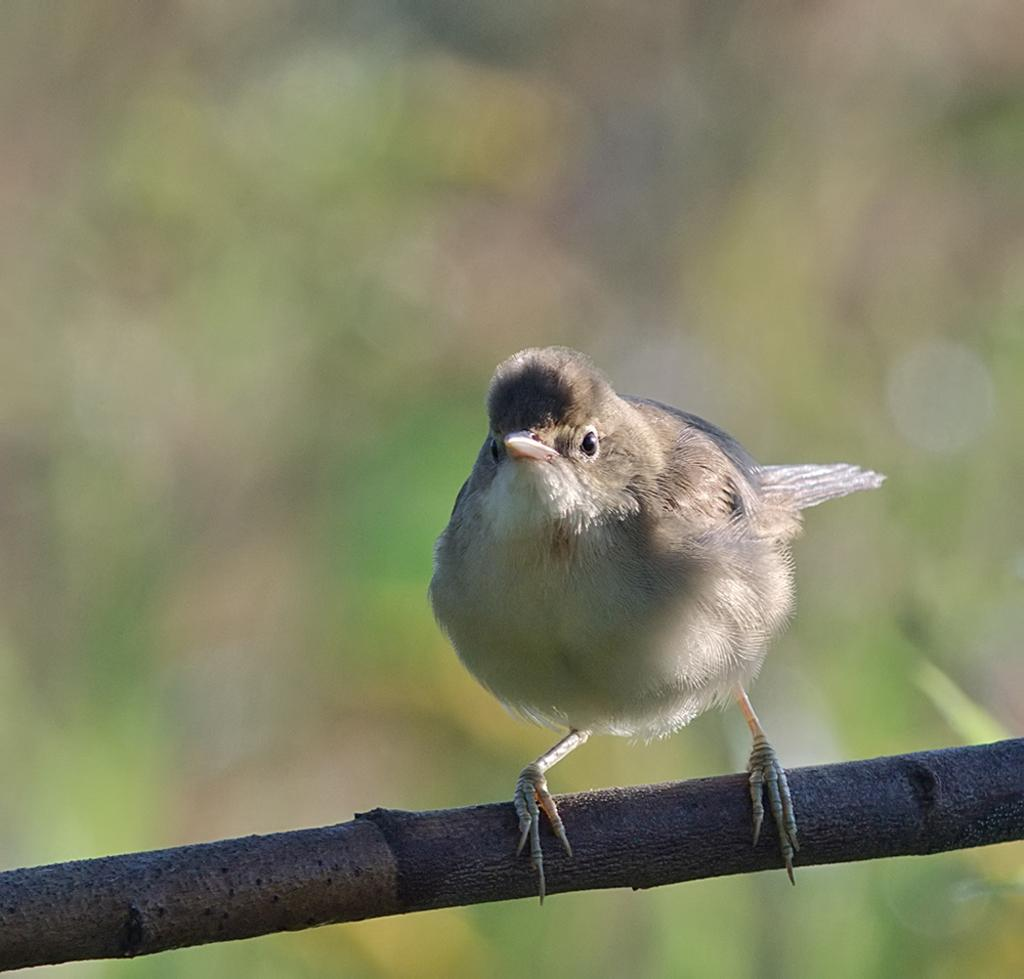What type of animal can be seen in the image? There is a bird in the image. Where is the bird located in the image? The bird is standing on a branch. What condition is the monkey in while standing on the branch in the image? There is no monkey present in the image; it only features a bird standing on a branch. 